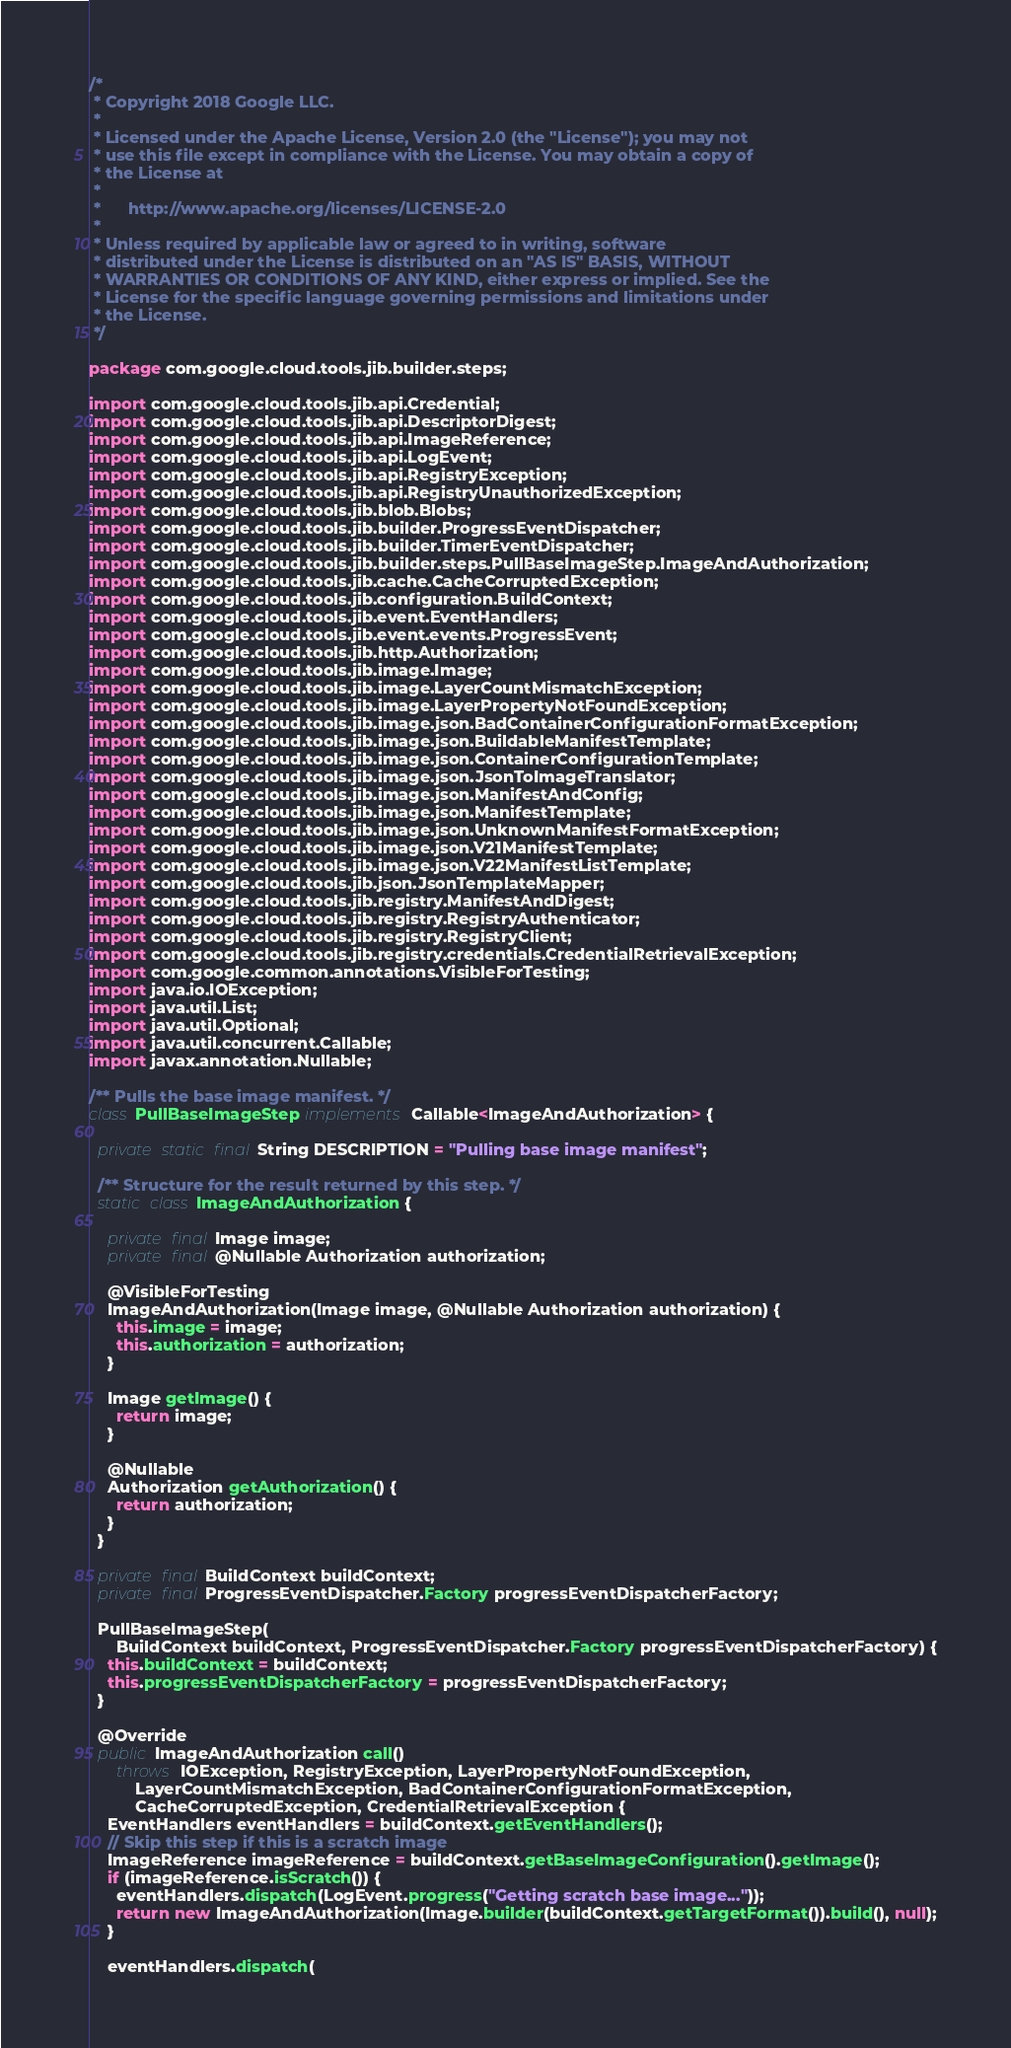Convert code to text. <code><loc_0><loc_0><loc_500><loc_500><_Java_>/*
 * Copyright 2018 Google LLC.
 *
 * Licensed under the Apache License, Version 2.0 (the "License"); you may not
 * use this file except in compliance with the License. You may obtain a copy of
 * the License at
 *
 *      http://www.apache.org/licenses/LICENSE-2.0
 *
 * Unless required by applicable law or agreed to in writing, software
 * distributed under the License is distributed on an "AS IS" BASIS, WITHOUT
 * WARRANTIES OR CONDITIONS OF ANY KIND, either express or implied. See the
 * License for the specific language governing permissions and limitations under
 * the License.
 */

package com.google.cloud.tools.jib.builder.steps;

import com.google.cloud.tools.jib.api.Credential;
import com.google.cloud.tools.jib.api.DescriptorDigest;
import com.google.cloud.tools.jib.api.ImageReference;
import com.google.cloud.tools.jib.api.LogEvent;
import com.google.cloud.tools.jib.api.RegistryException;
import com.google.cloud.tools.jib.api.RegistryUnauthorizedException;
import com.google.cloud.tools.jib.blob.Blobs;
import com.google.cloud.tools.jib.builder.ProgressEventDispatcher;
import com.google.cloud.tools.jib.builder.TimerEventDispatcher;
import com.google.cloud.tools.jib.builder.steps.PullBaseImageStep.ImageAndAuthorization;
import com.google.cloud.tools.jib.cache.CacheCorruptedException;
import com.google.cloud.tools.jib.configuration.BuildContext;
import com.google.cloud.tools.jib.event.EventHandlers;
import com.google.cloud.tools.jib.event.events.ProgressEvent;
import com.google.cloud.tools.jib.http.Authorization;
import com.google.cloud.tools.jib.image.Image;
import com.google.cloud.tools.jib.image.LayerCountMismatchException;
import com.google.cloud.tools.jib.image.LayerPropertyNotFoundException;
import com.google.cloud.tools.jib.image.json.BadContainerConfigurationFormatException;
import com.google.cloud.tools.jib.image.json.BuildableManifestTemplate;
import com.google.cloud.tools.jib.image.json.ContainerConfigurationTemplate;
import com.google.cloud.tools.jib.image.json.JsonToImageTranslator;
import com.google.cloud.tools.jib.image.json.ManifestAndConfig;
import com.google.cloud.tools.jib.image.json.ManifestTemplate;
import com.google.cloud.tools.jib.image.json.UnknownManifestFormatException;
import com.google.cloud.tools.jib.image.json.V21ManifestTemplate;
import com.google.cloud.tools.jib.image.json.V22ManifestListTemplate;
import com.google.cloud.tools.jib.json.JsonTemplateMapper;
import com.google.cloud.tools.jib.registry.ManifestAndDigest;
import com.google.cloud.tools.jib.registry.RegistryAuthenticator;
import com.google.cloud.tools.jib.registry.RegistryClient;
import com.google.cloud.tools.jib.registry.credentials.CredentialRetrievalException;
import com.google.common.annotations.VisibleForTesting;
import java.io.IOException;
import java.util.List;
import java.util.Optional;
import java.util.concurrent.Callable;
import javax.annotation.Nullable;

/** Pulls the base image manifest. */
class PullBaseImageStep implements Callable<ImageAndAuthorization> {

  private static final String DESCRIPTION = "Pulling base image manifest";

  /** Structure for the result returned by this step. */
  static class ImageAndAuthorization {

    private final Image image;
    private final @Nullable Authorization authorization;

    @VisibleForTesting
    ImageAndAuthorization(Image image, @Nullable Authorization authorization) {
      this.image = image;
      this.authorization = authorization;
    }

    Image getImage() {
      return image;
    }

    @Nullable
    Authorization getAuthorization() {
      return authorization;
    }
  }

  private final BuildContext buildContext;
  private final ProgressEventDispatcher.Factory progressEventDispatcherFactory;

  PullBaseImageStep(
      BuildContext buildContext, ProgressEventDispatcher.Factory progressEventDispatcherFactory) {
    this.buildContext = buildContext;
    this.progressEventDispatcherFactory = progressEventDispatcherFactory;
  }

  @Override
  public ImageAndAuthorization call()
      throws IOException, RegistryException, LayerPropertyNotFoundException,
          LayerCountMismatchException, BadContainerConfigurationFormatException,
          CacheCorruptedException, CredentialRetrievalException {
    EventHandlers eventHandlers = buildContext.getEventHandlers();
    // Skip this step if this is a scratch image
    ImageReference imageReference = buildContext.getBaseImageConfiguration().getImage();
    if (imageReference.isScratch()) {
      eventHandlers.dispatch(LogEvent.progress("Getting scratch base image..."));
      return new ImageAndAuthorization(Image.builder(buildContext.getTargetFormat()).build(), null);
    }

    eventHandlers.dispatch(</code> 